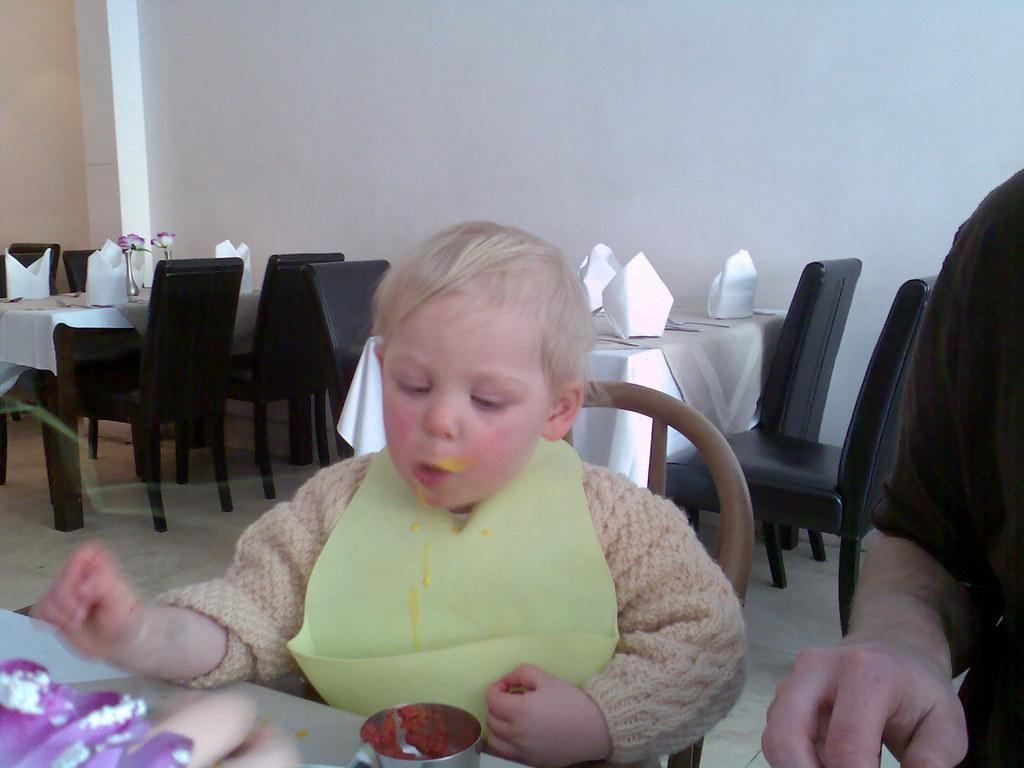In one or two sentences, can you explain what this image depicts? This image is clicked in a restaurant. In this image there are two persons, a kid in the middle and man to the right. In the background, there are many tables and chairs, and a wall in white color. The man is wearing black shirt and kid is wearing apron and eating food. 